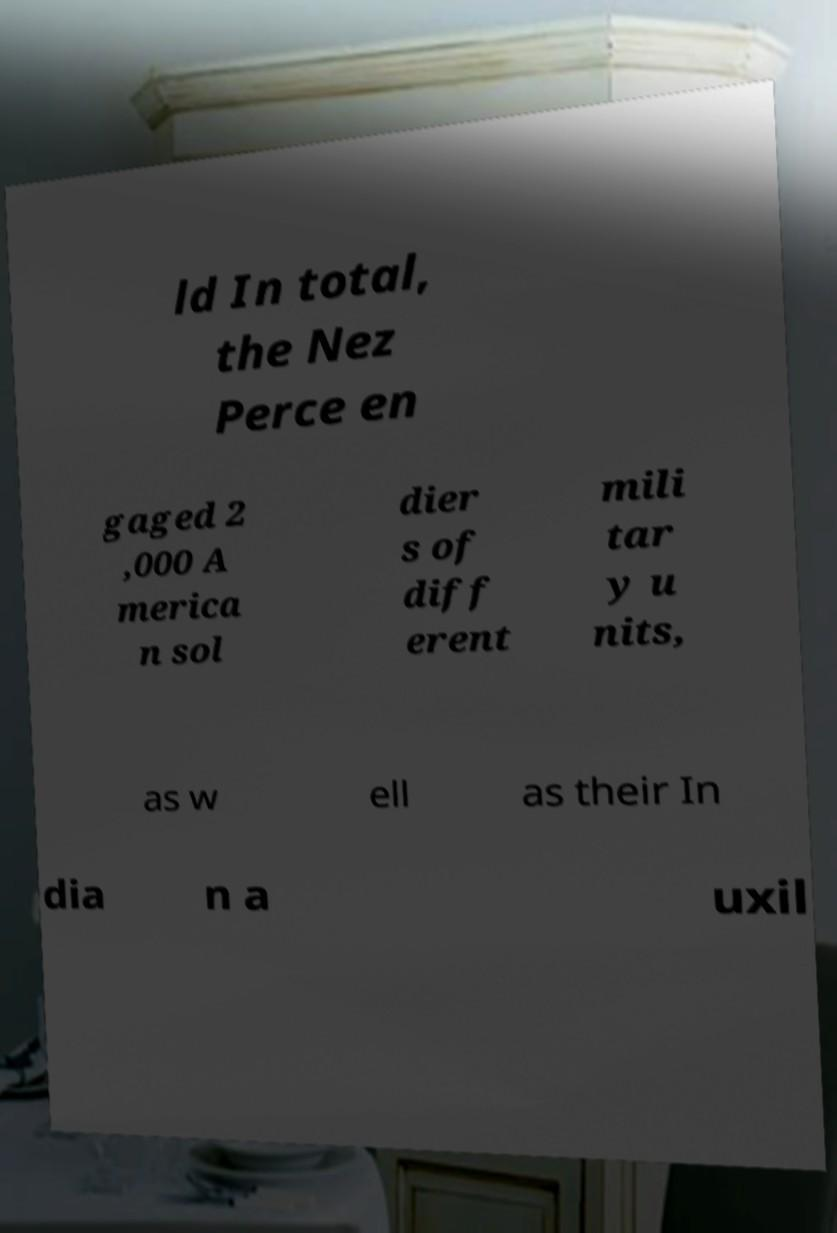Could you assist in decoding the text presented in this image and type it out clearly? ld In total, the Nez Perce en gaged 2 ,000 A merica n sol dier s of diff erent mili tar y u nits, as w ell as their In dia n a uxil 